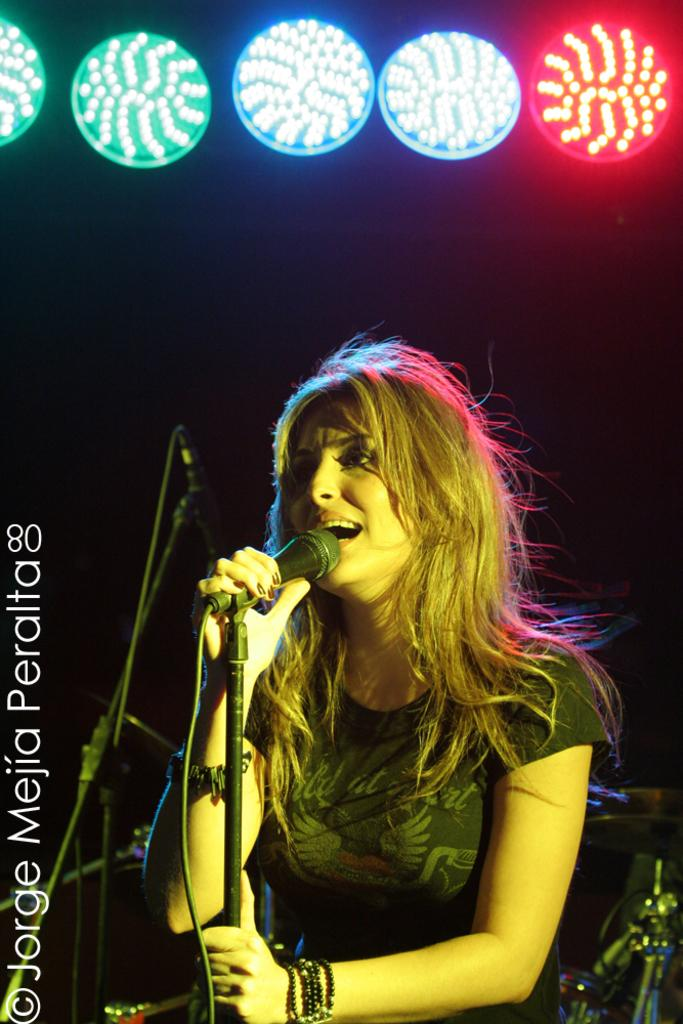Who is the main subject in the image? There is a woman in the image. What is the woman doing in the image? The woman is singing. What object is the woman holding in the image? The woman is holding a microphone. What can be seen above the woman in the image? There are colorful lights above the woman. Can you tell me how many snakes are slithering on the table in the image? There are no snakes or tables present in the image; it features a woman singing with a microphone and colorful lights above her. What type of activity is the snake participating in on the table? There is no snake or table present in the image, so it is not possible to determine what activity the snake might be participating in. 